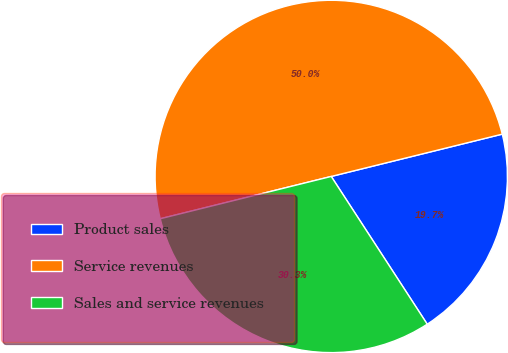Convert chart to OTSL. <chart><loc_0><loc_0><loc_500><loc_500><pie_chart><fcel>Product sales<fcel>Service revenues<fcel>Sales and service revenues<nl><fcel>19.69%<fcel>50.0%<fcel>30.31%<nl></chart> 